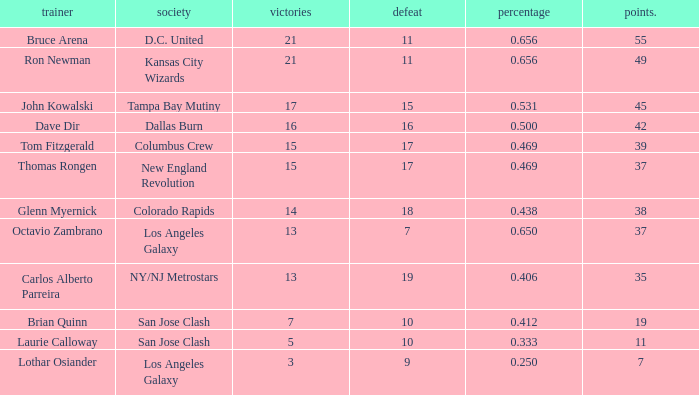What is the aggregate of points when bruce arena achieves 21 wins? 55.0. 